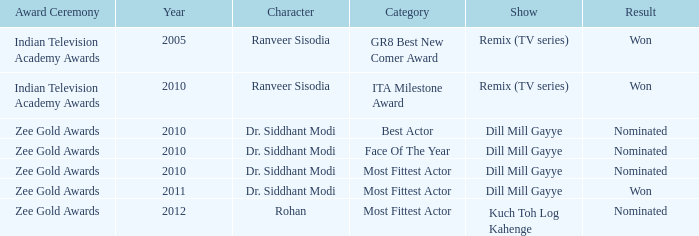Which show has a character of Rohan? Kuch Toh Log Kahenge. 